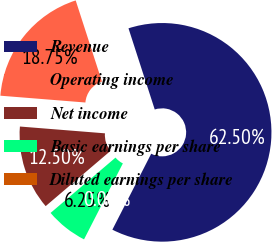Convert chart to OTSL. <chart><loc_0><loc_0><loc_500><loc_500><pie_chart><fcel>Revenue<fcel>Operating income<fcel>Net income<fcel>Basic earnings per share<fcel>Diluted earnings per share<nl><fcel>62.5%<fcel>18.75%<fcel>12.5%<fcel>6.25%<fcel>0.0%<nl></chart> 